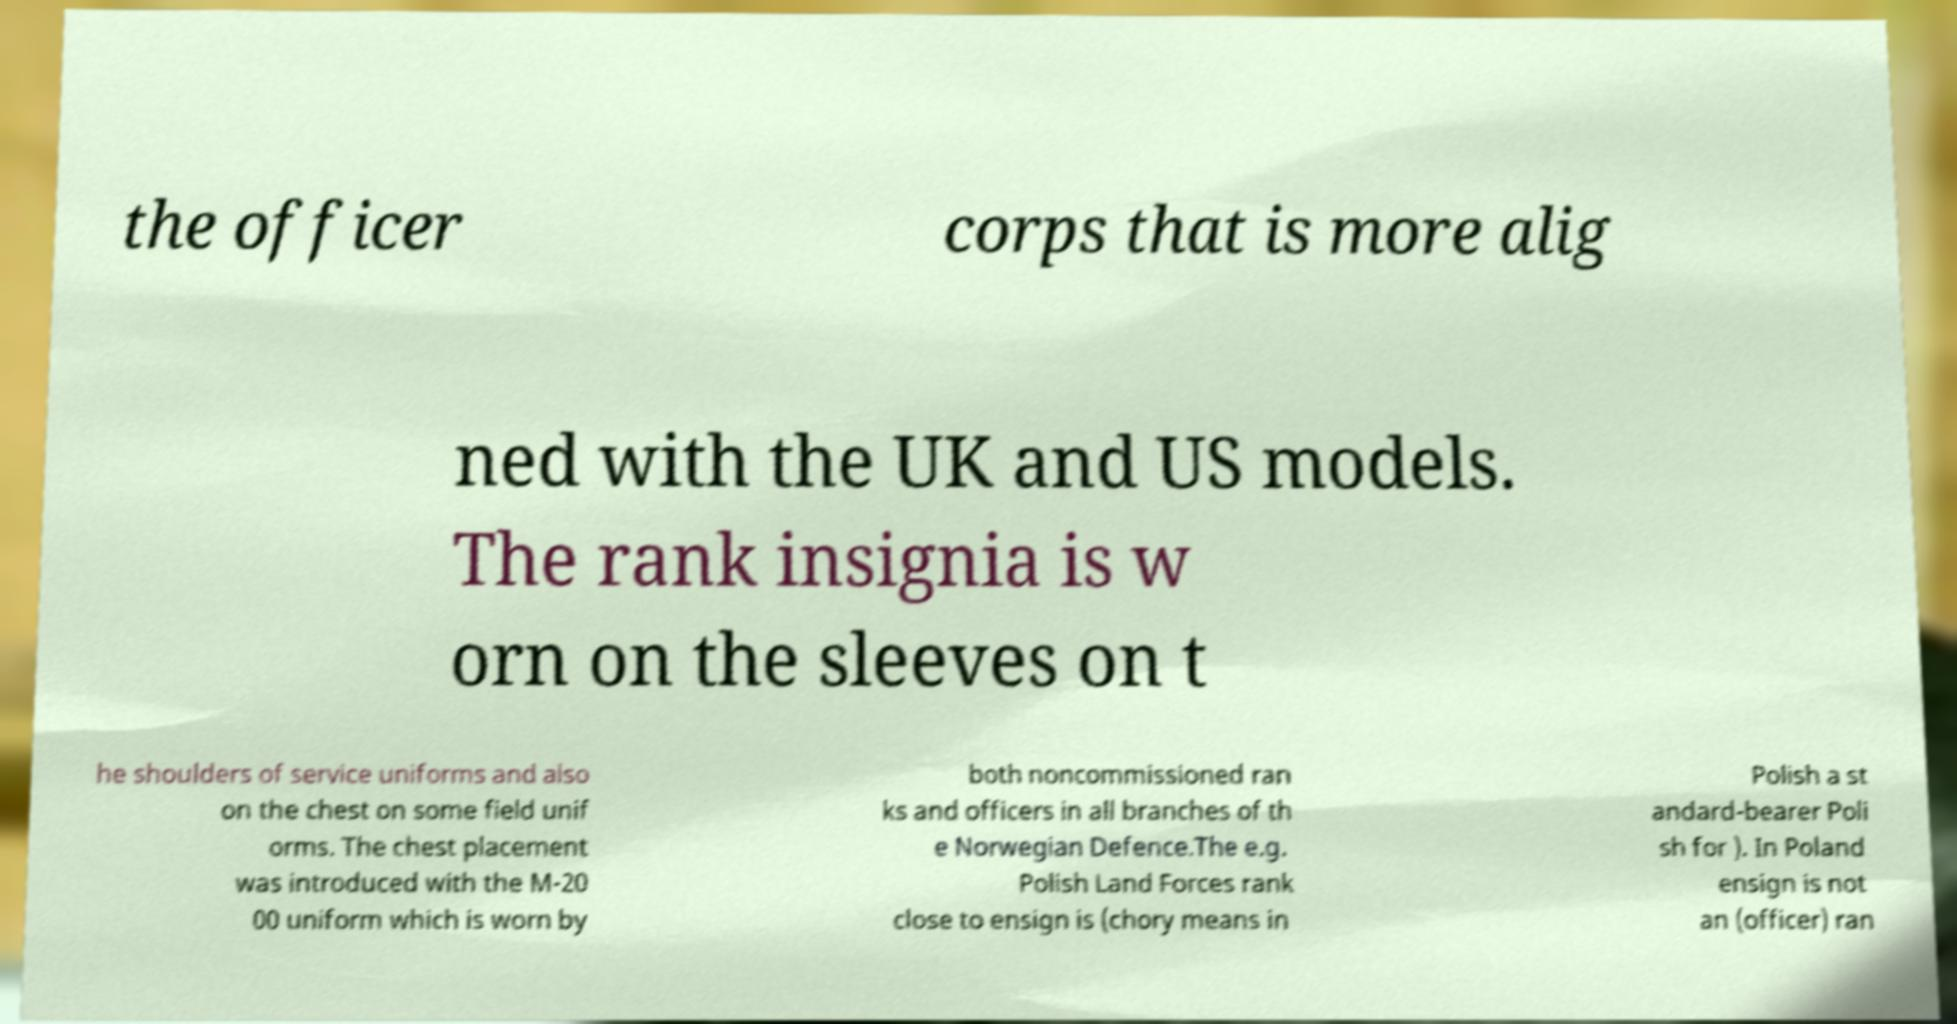I need the written content from this picture converted into text. Can you do that? the officer corps that is more alig ned with the UK and US models. The rank insignia is w orn on the sleeves on t he shoulders of service uniforms and also on the chest on some field unif orms. The chest placement was introduced with the M-20 00 uniform which is worn by both noncommissioned ran ks and officers in all branches of th e Norwegian Defence.The e.g. Polish Land Forces rank close to ensign is (chory means in Polish a st andard-bearer Poli sh for ). In Poland ensign is not an (officer) ran 